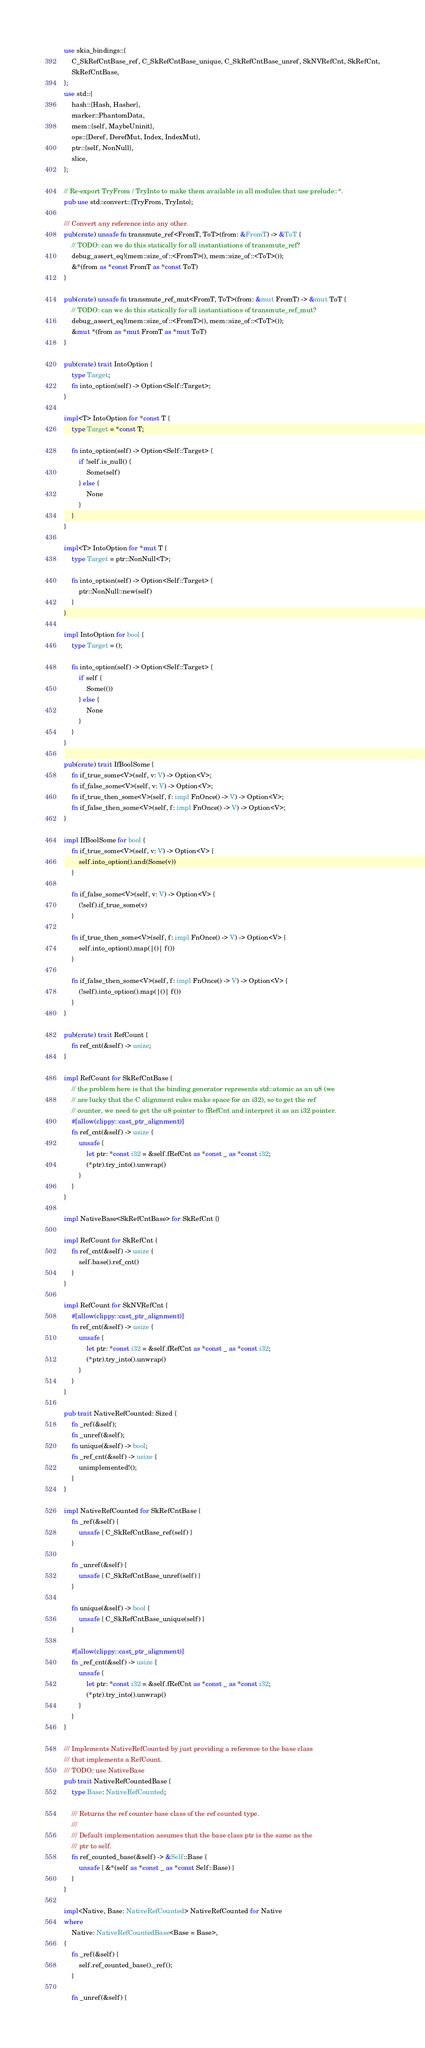<code> <loc_0><loc_0><loc_500><loc_500><_Rust_>use skia_bindings::{
    C_SkRefCntBase_ref, C_SkRefCntBase_unique, C_SkRefCntBase_unref, SkNVRefCnt, SkRefCnt,
    SkRefCntBase,
};
use std::{
    hash::{Hash, Hasher},
    marker::PhantomData,
    mem::{self, MaybeUninit},
    ops::{Deref, DerefMut, Index, IndexMut},
    ptr::{self, NonNull},
    slice,
};

// Re-export TryFrom / TryInto to make them available in all modules that use prelude::*.
pub use std::convert::{TryFrom, TryInto};

/// Convert any reference into any other.
pub(crate) unsafe fn transmute_ref<FromT, ToT>(from: &FromT) -> &ToT {
    // TODO: can we do this statically for all instantiations of transmute_ref?
    debug_assert_eq!(mem::size_of::<FromT>(), mem::size_of::<ToT>());
    &*(from as *const FromT as *const ToT)
}

pub(crate) unsafe fn transmute_ref_mut<FromT, ToT>(from: &mut FromT) -> &mut ToT {
    // TODO: can we do this statically for all instantiations of transmute_ref_mut?
    debug_assert_eq!(mem::size_of::<FromT>(), mem::size_of::<ToT>());
    &mut *(from as *mut FromT as *mut ToT)
}

pub(crate) trait IntoOption {
    type Target;
    fn into_option(self) -> Option<Self::Target>;
}

impl<T> IntoOption for *const T {
    type Target = *const T;

    fn into_option(self) -> Option<Self::Target> {
        if !self.is_null() {
            Some(self)
        } else {
            None
        }
    }
}

impl<T> IntoOption for *mut T {
    type Target = ptr::NonNull<T>;

    fn into_option(self) -> Option<Self::Target> {
        ptr::NonNull::new(self)
    }
}

impl IntoOption for bool {
    type Target = ();

    fn into_option(self) -> Option<Self::Target> {
        if self {
            Some(())
        } else {
            None
        }
    }
}

pub(crate) trait IfBoolSome {
    fn if_true_some<V>(self, v: V) -> Option<V>;
    fn if_false_some<V>(self, v: V) -> Option<V>;
    fn if_true_then_some<V>(self, f: impl FnOnce() -> V) -> Option<V>;
    fn if_false_then_some<V>(self, f: impl FnOnce() -> V) -> Option<V>;
}

impl IfBoolSome for bool {
    fn if_true_some<V>(self, v: V) -> Option<V> {
        self.into_option().and(Some(v))
    }

    fn if_false_some<V>(self, v: V) -> Option<V> {
        (!self).if_true_some(v)
    }

    fn if_true_then_some<V>(self, f: impl FnOnce() -> V) -> Option<V> {
        self.into_option().map(|()| f())
    }

    fn if_false_then_some<V>(self, f: impl FnOnce() -> V) -> Option<V> {
        (!self).into_option().map(|()| f())
    }
}

pub(crate) trait RefCount {
    fn ref_cnt(&self) -> usize;
}

impl RefCount for SkRefCntBase {
    // the problem here is that the binding generator represents std::atomic as an u8 (we
    // are lucky that the C alignment rules make space for an i32), so to get the ref
    // counter, we need to get the u8 pointer to fRefCnt and interpret it as an i32 pointer.
    #[allow(clippy::cast_ptr_alignment)]
    fn ref_cnt(&self) -> usize {
        unsafe {
            let ptr: *const i32 = &self.fRefCnt as *const _ as *const i32;
            (*ptr).try_into().unwrap()
        }
    }
}

impl NativeBase<SkRefCntBase> for SkRefCnt {}

impl RefCount for SkRefCnt {
    fn ref_cnt(&self) -> usize {
        self.base().ref_cnt()
    }
}

impl RefCount for SkNVRefCnt {
    #[allow(clippy::cast_ptr_alignment)]
    fn ref_cnt(&self) -> usize {
        unsafe {
            let ptr: *const i32 = &self.fRefCnt as *const _ as *const i32;
            (*ptr).try_into().unwrap()
        }
    }
}

pub trait NativeRefCounted: Sized {
    fn _ref(&self);
    fn _unref(&self);
    fn unique(&self) -> bool;
    fn _ref_cnt(&self) -> usize {
        unimplemented!();
    }
}

impl NativeRefCounted for SkRefCntBase {
    fn _ref(&self) {
        unsafe { C_SkRefCntBase_ref(self) }
    }

    fn _unref(&self) {
        unsafe { C_SkRefCntBase_unref(self) }
    }

    fn unique(&self) -> bool {
        unsafe { C_SkRefCntBase_unique(self) }
    }

    #[allow(clippy::cast_ptr_alignment)]
    fn _ref_cnt(&self) -> usize {
        unsafe {
            let ptr: *const i32 = &self.fRefCnt as *const _ as *const i32;
            (*ptr).try_into().unwrap()
        }
    }
}

/// Implements NativeRefCounted by just providing a reference to the base class
/// that implements a RefCount.
/// TODO: use NativeBase
pub trait NativeRefCountedBase {
    type Base: NativeRefCounted;

    /// Returns the ref counter base class of the ref counted type.
    ///
    /// Default implementation assumes that the base class ptr is the same as the
    /// ptr to self.
    fn ref_counted_base(&self) -> &Self::Base {
        unsafe { &*(self as *const _ as *const Self::Base) }
    }
}

impl<Native, Base: NativeRefCounted> NativeRefCounted for Native
where
    Native: NativeRefCountedBase<Base = Base>,
{
    fn _ref(&self) {
        self.ref_counted_base()._ref();
    }

    fn _unref(&self) {</code> 